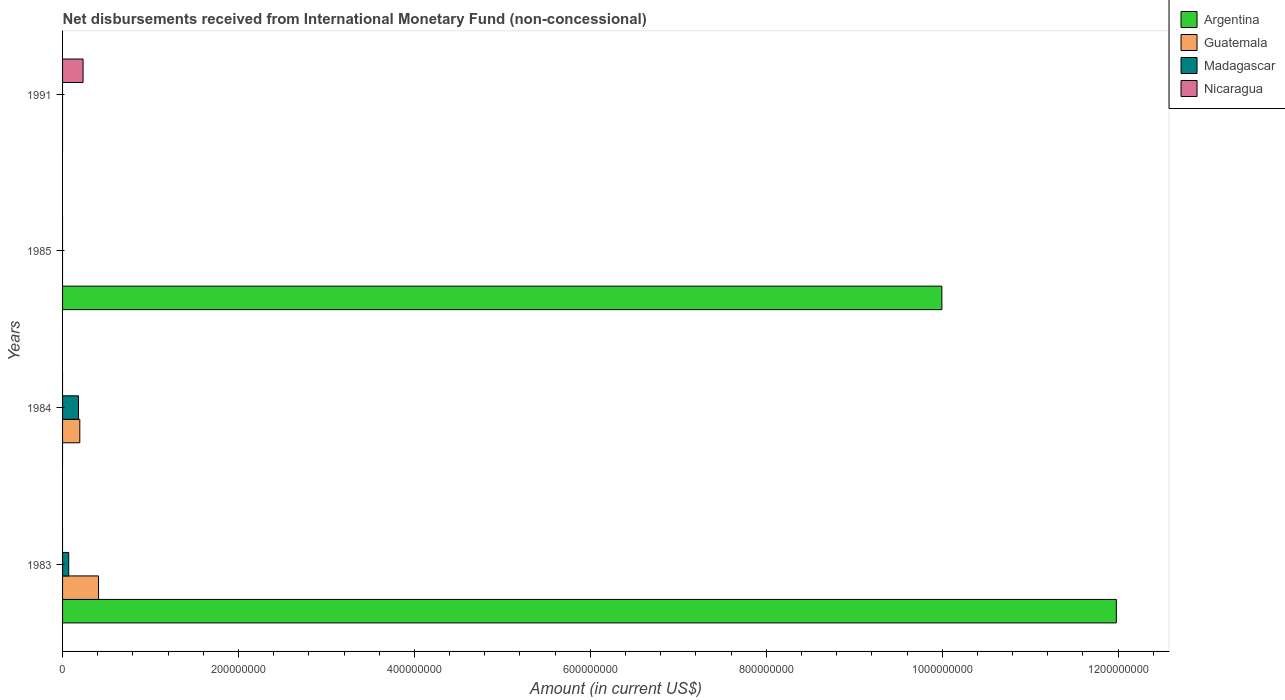How many bars are there on the 4th tick from the bottom?
Your answer should be compact. 1. What is the amount of disbursements received from International Monetary Fund in Guatemala in 1984?
Ensure brevity in your answer.  1.96e+07. Across all years, what is the maximum amount of disbursements received from International Monetary Fund in Nicaragua?
Make the answer very short. 2.33e+07. What is the total amount of disbursements received from International Monetary Fund in Guatemala in the graph?
Ensure brevity in your answer.  6.05e+07. What is the difference between the amount of disbursements received from International Monetary Fund in Guatemala in 1985 and the amount of disbursements received from International Monetary Fund in Argentina in 1983?
Your response must be concise. -1.20e+09. What is the average amount of disbursements received from International Monetary Fund in Argentina per year?
Your answer should be very brief. 5.49e+08. In the year 1983, what is the difference between the amount of disbursements received from International Monetary Fund in Argentina and amount of disbursements received from International Monetary Fund in Guatemala?
Provide a succinct answer. 1.16e+09. What is the difference between the highest and the lowest amount of disbursements received from International Monetary Fund in Nicaragua?
Keep it short and to the point. 2.33e+07. In how many years, is the amount of disbursements received from International Monetary Fund in Madagascar greater than the average amount of disbursements received from International Monetary Fund in Madagascar taken over all years?
Your answer should be compact. 2. Is it the case that in every year, the sum of the amount of disbursements received from International Monetary Fund in Madagascar and amount of disbursements received from International Monetary Fund in Guatemala is greater than the sum of amount of disbursements received from International Monetary Fund in Argentina and amount of disbursements received from International Monetary Fund in Nicaragua?
Ensure brevity in your answer.  No. Is it the case that in every year, the sum of the amount of disbursements received from International Monetary Fund in Nicaragua and amount of disbursements received from International Monetary Fund in Guatemala is greater than the amount of disbursements received from International Monetary Fund in Madagascar?
Your answer should be very brief. No. How many bars are there?
Offer a terse response. 7. How many years are there in the graph?
Offer a very short reply. 4. What is the difference between two consecutive major ticks on the X-axis?
Make the answer very short. 2.00e+08. Does the graph contain any zero values?
Ensure brevity in your answer.  Yes. Where does the legend appear in the graph?
Provide a short and direct response. Top right. How many legend labels are there?
Your answer should be compact. 4. What is the title of the graph?
Offer a terse response. Net disbursements received from International Monetary Fund (non-concessional). Does "Europe(developing only)" appear as one of the legend labels in the graph?
Your answer should be compact. No. What is the label or title of the X-axis?
Make the answer very short. Amount (in current US$). What is the Amount (in current US$) in Argentina in 1983?
Offer a very short reply. 1.20e+09. What is the Amount (in current US$) in Guatemala in 1983?
Your response must be concise. 4.09e+07. What is the Amount (in current US$) of Argentina in 1984?
Your answer should be very brief. 0. What is the Amount (in current US$) of Guatemala in 1984?
Offer a terse response. 1.96e+07. What is the Amount (in current US$) in Madagascar in 1984?
Provide a succinct answer. 1.81e+07. What is the Amount (in current US$) in Argentina in 1985?
Offer a very short reply. 1.00e+09. What is the Amount (in current US$) in Madagascar in 1985?
Your answer should be compact. 0. What is the Amount (in current US$) in Guatemala in 1991?
Keep it short and to the point. 0. What is the Amount (in current US$) in Madagascar in 1991?
Keep it short and to the point. 0. What is the Amount (in current US$) of Nicaragua in 1991?
Provide a short and direct response. 2.33e+07. Across all years, what is the maximum Amount (in current US$) of Argentina?
Provide a succinct answer. 1.20e+09. Across all years, what is the maximum Amount (in current US$) of Guatemala?
Ensure brevity in your answer.  4.09e+07. Across all years, what is the maximum Amount (in current US$) of Madagascar?
Provide a short and direct response. 1.81e+07. Across all years, what is the maximum Amount (in current US$) of Nicaragua?
Make the answer very short. 2.33e+07. Across all years, what is the minimum Amount (in current US$) in Argentina?
Provide a succinct answer. 0. Across all years, what is the minimum Amount (in current US$) in Guatemala?
Make the answer very short. 0. Across all years, what is the minimum Amount (in current US$) in Madagascar?
Keep it short and to the point. 0. Across all years, what is the minimum Amount (in current US$) in Nicaragua?
Your answer should be very brief. 0. What is the total Amount (in current US$) in Argentina in the graph?
Offer a terse response. 2.20e+09. What is the total Amount (in current US$) in Guatemala in the graph?
Offer a terse response. 6.05e+07. What is the total Amount (in current US$) in Madagascar in the graph?
Your answer should be compact. 2.51e+07. What is the total Amount (in current US$) of Nicaragua in the graph?
Your answer should be very brief. 2.33e+07. What is the difference between the Amount (in current US$) of Guatemala in 1983 and that in 1984?
Ensure brevity in your answer.  2.13e+07. What is the difference between the Amount (in current US$) in Madagascar in 1983 and that in 1984?
Offer a very short reply. -1.11e+07. What is the difference between the Amount (in current US$) of Argentina in 1983 and that in 1985?
Your response must be concise. 1.98e+08. What is the difference between the Amount (in current US$) of Argentina in 1983 and the Amount (in current US$) of Guatemala in 1984?
Provide a short and direct response. 1.18e+09. What is the difference between the Amount (in current US$) in Argentina in 1983 and the Amount (in current US$) in Madagascar in 1984?
Give a very brief answer. 1.18e+09. What is the difference between the Amount (in current US$) of Guatemala in 1983 and the Amount (in current US$) of Madagascar in 1984?
Make the answer very short. 2.28e+07. What is the difference between the Amount (in current US$) in Argentina in 1983 and the Amount (in current US$) in Nicaragua in 1991?
Offer a terse response. 1.17e+09. What is the difference between the Amount (in current US$) in Guatemala in 1983 and the Amount (in current US$) in Nicaragua in 1991?
Ensure brevity in your answer.  1.76e+07. What is the difference between the Amount (in current US$) of Madagascar in 1983 and the Amount (in current US$) of Nicaragua in 1991?
Give a very brief answer. -1.63e+07. What is the difference between the Amount (in current US$) in Guatemala in 1984 and the Amount (in current US$) in Nicaragua in 1991?
Your answer should be very brief. -3.71e+06. What is the difference between the Amount (in current US$) of Madagascar in 1984 and the Amount (in current US$) of Nicaragua in 1991?
Your response must be concise. -5.21e+06. What is the difference between the Amount (in current US$) of Argentina in 1985 and the Amount (in current US$) of Nicaragua in 1991?
Make the answer very short. 9.76e+08. What is the average Amount (in current US$) in Argentina per year?
Your response must be concise. 5.49e+08. What is the average Amount (in current US$) of Guatemala per year?
Your answer should be compact. 1.51e+07. What is the average Amount (in current US$) of Madagascar per year?
Ensure brevity in your answer.  6.28e+06. What is the average Amount (in current US$) of Nicaragua per year?
Your answer should be very brief. 5.83e+06. In the year 1983, what is the difference between the Amount (in current US$) of Argentina and Amount (in current US$) of Guatemala?
Give a very brief answer. 1.16e+09. In the year 1983, what is the difference between the Amount (in current US$) in Argentina and Amount (in current US$) in Madagascar?
Keep it short and to the point. 1.19e+09. In the year 1983, what is the difference between the Amount (in current US$) of Guatemala and Amount (in current US$) of Madagascar?
Offer a terse response. 3.39e+07. In the year 1984, what is the difference between the Amount (in current US$) of Guatemala and Amount (in current US$) of Madagascar?
Keep it short and to the point. 1.50e+06. What is the ratio of the Amount (in current US$) in Guatemala in 1983 to that in 1984?
Ensure brevity in your answer.  2.09. What is the ratio of the Amount (in current US$) of Madagascar in 1983 to that in 1984?
Your answer should be very brief. 0.39. What is the ratio of the Amount (in current US$) of Argentina in 1983 to that in 1985?
Ensure brevity in your answer.  1.2. What is the difference between the highest and the lowest Amount (in current US$) in Argentina?
Ensure brevity in your answer.  1.20e+09. What is the difference between the highest and the lowest Amount (in current US$) of Guatemala?
Your answer should be very brief. 4.09e+07. What is the difference between the highest and the lowest Amount (in current US$) of Madagascar?
Offer a terse response. 1.81e+07. What is the difference between the highest and the lowest Amount (in current US$) of Nicaragua?
Ensure brevity in your answer.  2.33e+07. 